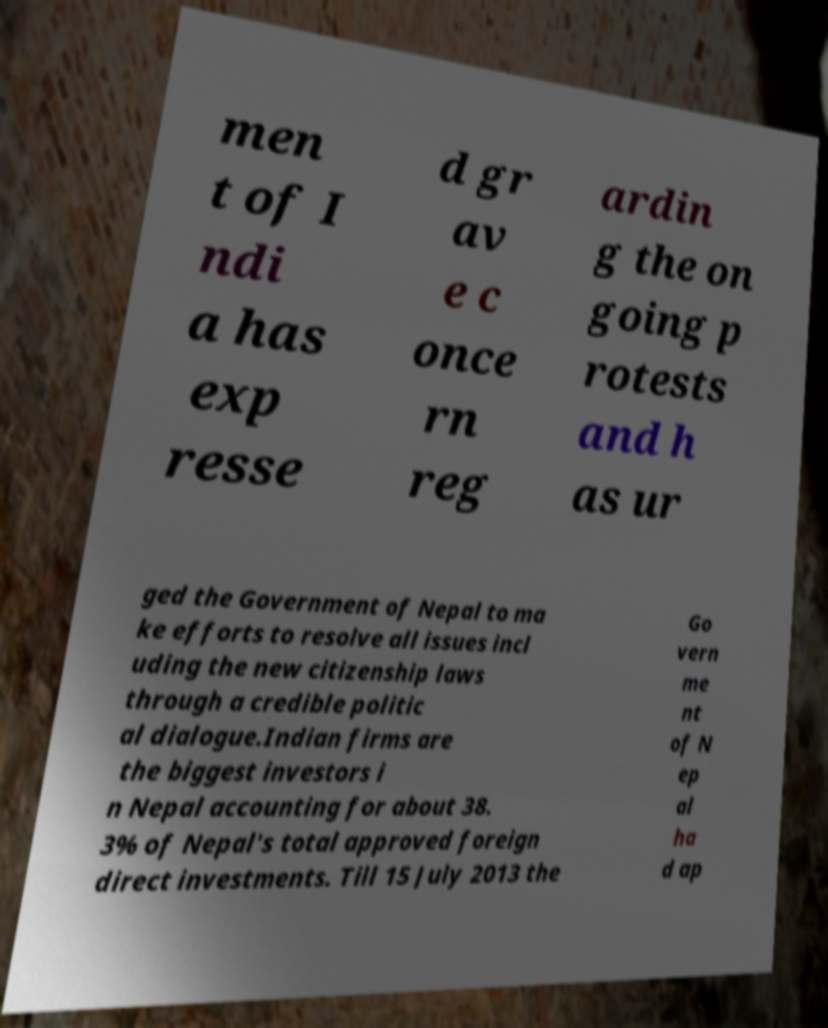Could you assist in decoding the text presented in this image and type it out clearly? men t of I ndi a has exp resse d gr av e c once rn reg ardin g the on going p rotests and h as ur ged the Government of Nepal to ma ke efforts to resolve all issues incl uding the new citizenship laws through a credible politic al dialogue.Indian firms are the biggest investors i n Nepal accounting for about 38. 3% of Nepal's total approved foreign direct investments. Till 15 July 2013 the Go vern me nt of N ep al ha d ap 